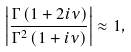Convert formula to latex. <formula><loc_0><loc_0><loc_500><loc_500>\left | \frac { \Gamma \left ( 1 + 2 i \nu \right ) } { \Gamma ^ { 2 } \left ( 1 + i \nu \right ) } \right | \approx 1 ,</formula> 